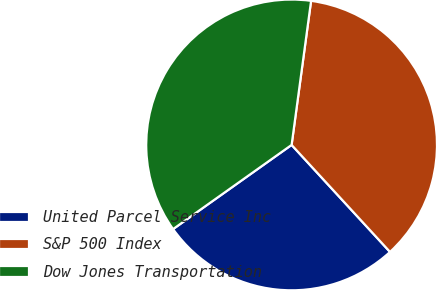Convert chart to OTSL. <chart><loc_0><loc_0><loc_500><loc_500><pie_chart><fcel>United Parcel Service Inc<fcel>S&P 500 Index<fcel>Dow Jones Transportation<nl><fcel>27.01%<fcel>36.03%<fcel>36.97%<nl></chart> 